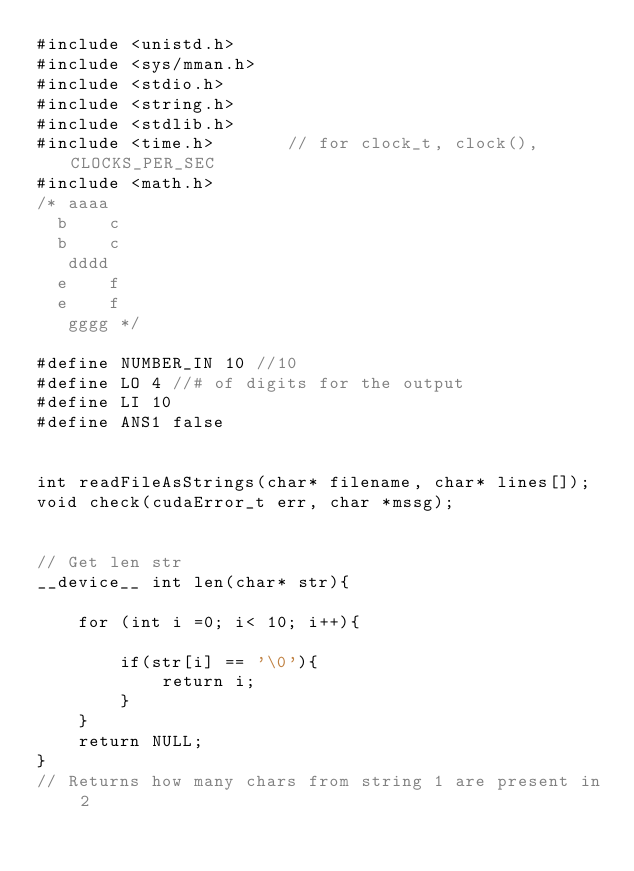Convert code to text. <code><loc_0><loc_0><loc_500><loc_500><_Cuda_>#include <unistd.h>
#include <sys/mman.h>
#include <stdio.h>
#include <string.h>
#include <stdlib.h>
#include <time.h>       // for clock_t, clock(), CLOCKS_PER_SEC
#include <math.h>
/* aaaa
  b    c
  b    c  
   dddd 
  e    f
  e    f
   gggg */

#define NUMBER_IN 10 //10
#define LO 4 //# of digits for the output
#define LI 10
#define ANS1 false


int readFileAsStrings(char* filename, char* lines[]);
void check(cudaError_t err, char *mssg);


// Get len str
__device__ int len(char* str){

    for (int i =0; i< 10; i++){

        if(str[i] == '\0'){
            return i;
        }
    }
    return NULL;
}
// Returns how many chars from string 1 are present in 2</code> 